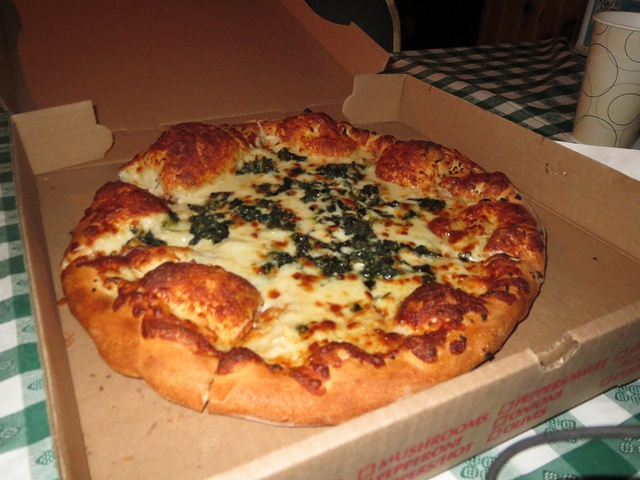Describe the objects in this image and their specific colors. I can see pizza in black, brown, orange, and maroon tones, dining table in black, gray, lightgray, darkgray, and teal tones, dining table in black, gray, and maroon tones, and cup in black, gray, and maroon tones in this image. 